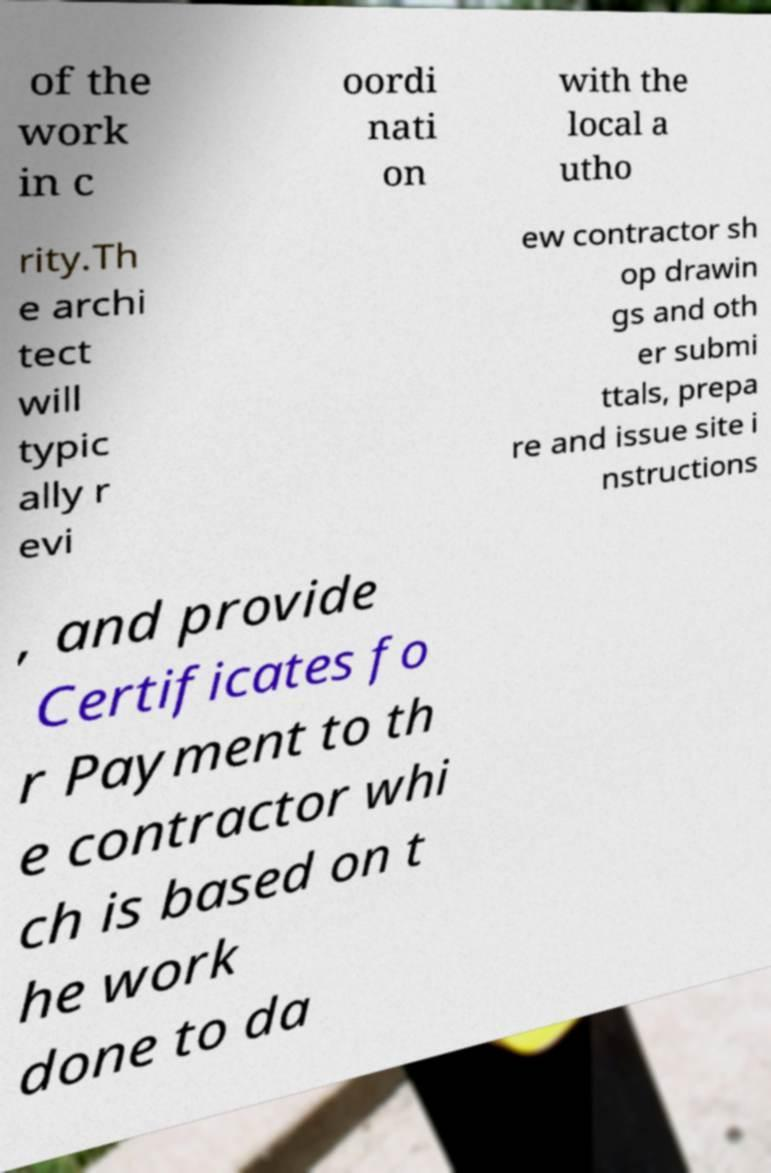Can you accurately transcribe the text from the provided image for me? of the work in c oordi nati on with the local a utho rity.Th e archi tect will typic ally r evi ew contractor sh op drawin gs and oth er submi ttals, prepa re and issue site i nstructions , and provide Certificates fo r Payment to th e contractor whi ch is based on t he work done to da 